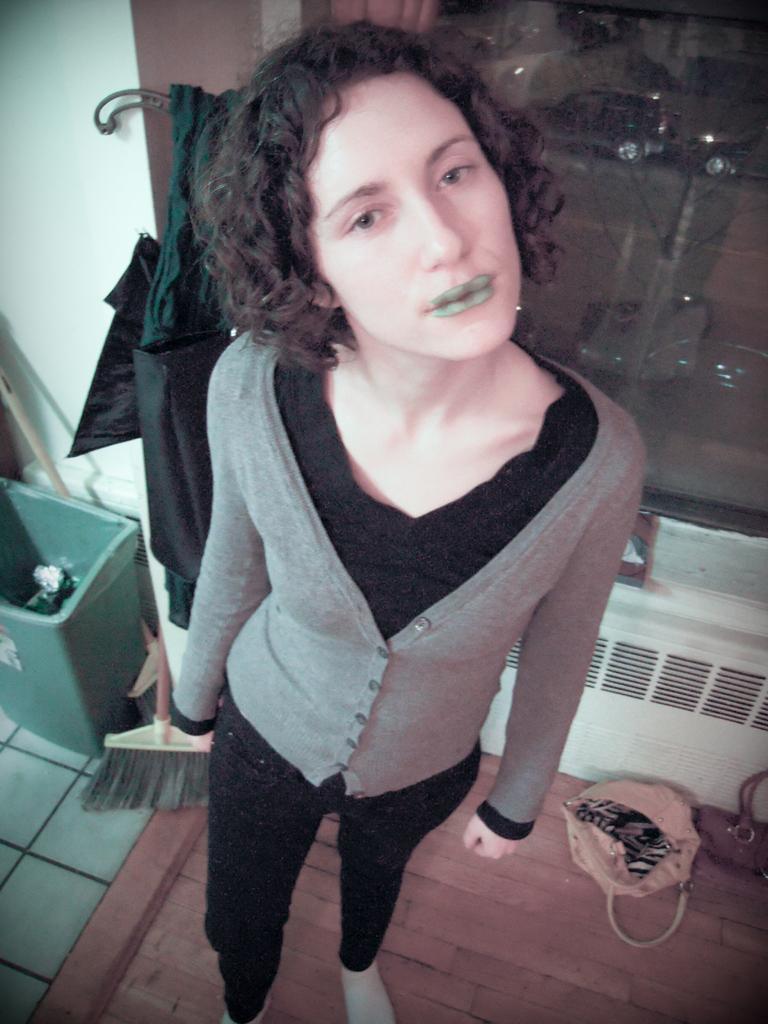Describe this image in one or two sentences. In this picture there is a woman who is standing near to the window. On the left I can see the dustbin. On the right I can see bag which is placed on the wooden floor. Behind her I can see the jacket. 